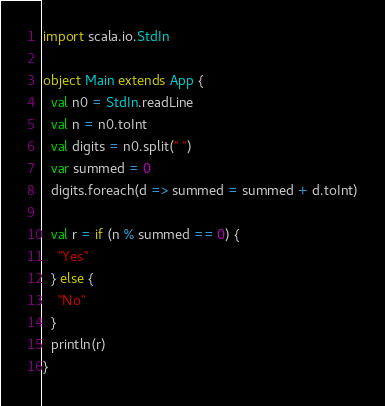Convert code to text. <code><loc_0><loc_0><loc_500><loc_500><_Scala_>import scala.io.StdIn

object Main extends App {
  val n0 = StdIn.readLine
  val n = n0.toInt
  val digits = n0.split(" ")
  var summed = 0
  digits.foreach(d => summed = summed + d.toInt)

  val r = if (n % summed == 0) {
    "Yes"
  } else {
    "No"
  }
  println(r)
}</code> 